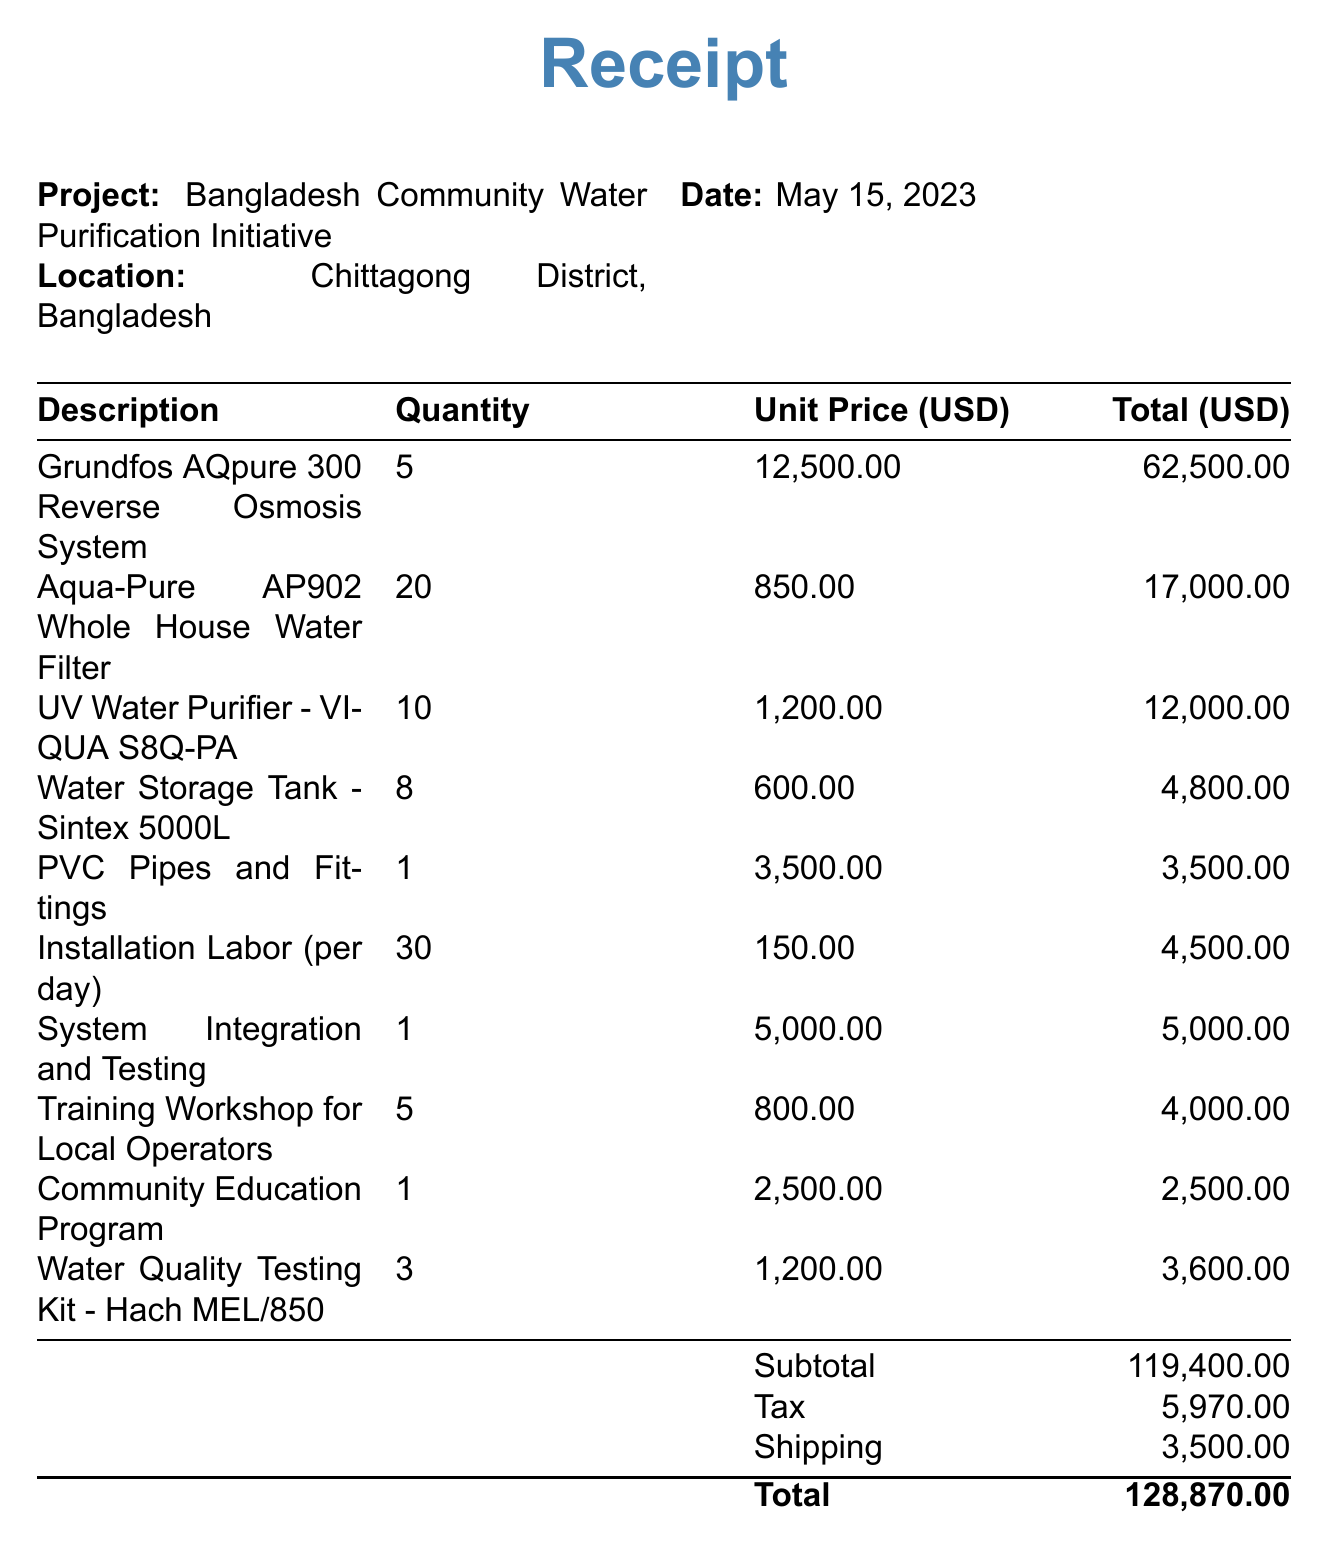What is the receipt number? The receipt number is specifically provided in the document for reference.
Answer: INV-2023-0542 What is the total cost of the water purification systems? The total cost reflects the sum of all items, taxes, and shipping charges.
Answer: 128870 How many Aqua-Pure AP902 Whole House Water Filters were purchased? The quantity of Aqua-Pure AP902 Whole House Water Filters is stated clearly in the list of items.
Answer: 20 What was the unit price of the Grundfos AQpure 300 Reverse Osmosis System? The unit price is explicitly mentioned next to the description of the item.
Answer: 12500 What is the date of the receipt? The date is noted at the top of the receipt for record-keeping purposes.
Answer: May 15, 2023 What project is this receipt associated with? The project title is mentioned at the top of the document indicating its purpose.
Answer: Bangladesh Community Water Purification Initiative How much was charged for training workshops for local operators? The costs for training workshops are specified in the table of items.
Answer: 4000 Which payment terms are indicated? The payment terms provide information on how long the buyer has to make the payment.
Answer: Net 30 What is the subtotal amount before tax and shipping? The subtotal is provided in the document before additional charges are calculated.
Answer: 119400 